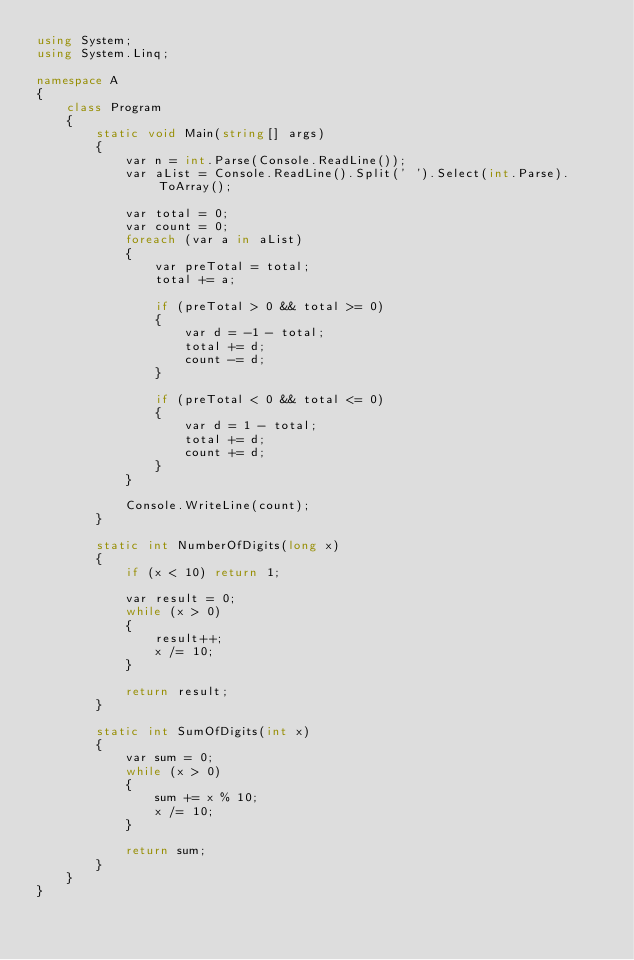<code> <loc_0><loc_0><loc_500><loc_500><_C#_>using System;
using System.Linq;

namespace A
{
    class Program
    {
        static void Main(string[] args)
        {
            var n = int.Parse(Console.ReadLine());
            var aList = Console.ReadLine().Split(' ').Select(int.Parse).ToArray();

            var total = 0;
            var count = 0;
            foreach (var a in aList)
            {
                var preTotal = total;
                total += a;

                if (preTotal > 0 && total >= 0)
                {
                    var d = -1 - total;
                    total += d;
                    count -= d;
                }

                if (preTotal < 0 && total <= 0)
                {
                    var d = 1 - total;
                    total += d;
                    count += d;
                }
            }

            Console.WriteLine(count);
        }

        static int NumberOfDigits(long x)
        {
            if (x < 10) return 1;

            var result = 0;
            while (x > 0)
            {
                result++;
                x /= 10;
            }

            return result;
        }

        static int SumOfDigits(int x)
        {
            var sum = 0;
            while (x > 0)
            {
                sum += x % 10;
                x /= 10;
            }

            return sum;
        }
    }
}
</code> 